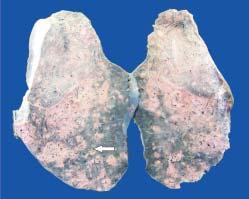what shows presence of minute millet-seed sized tubercles?
Answer the question using a single word or phrase. The sectioned surface of the lung 